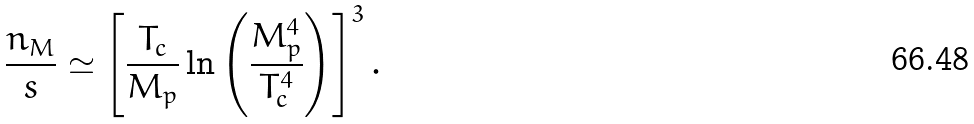Convert formula to latex. <formula><loc_0><loc_0><loc_500><loc_500>\frac { n _ { M } } { s } \simeq \left [ \frac { T _ { c } } { M _ { p } } \ln \left ( \frac { M _ { p } ^ { 4 } } { T _ { c } ^ { 4 } } \right ) \right ] ^ { 3 } .</formula> 